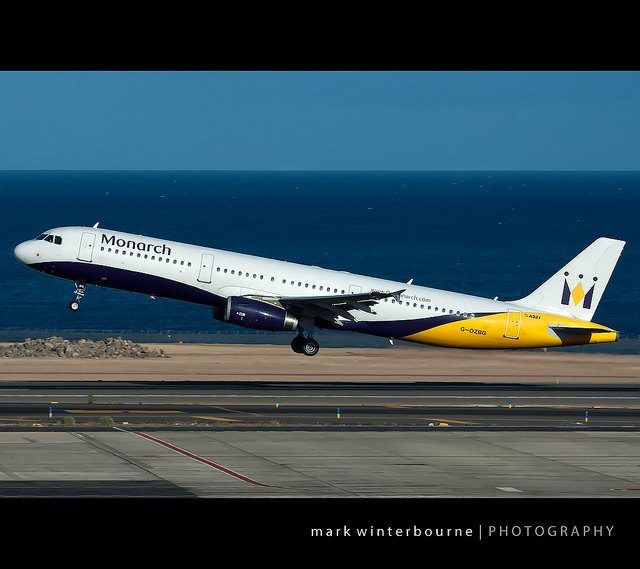Please transcribe the text information in this image. monarch mark winter bourne PHOTOGRAPHY 